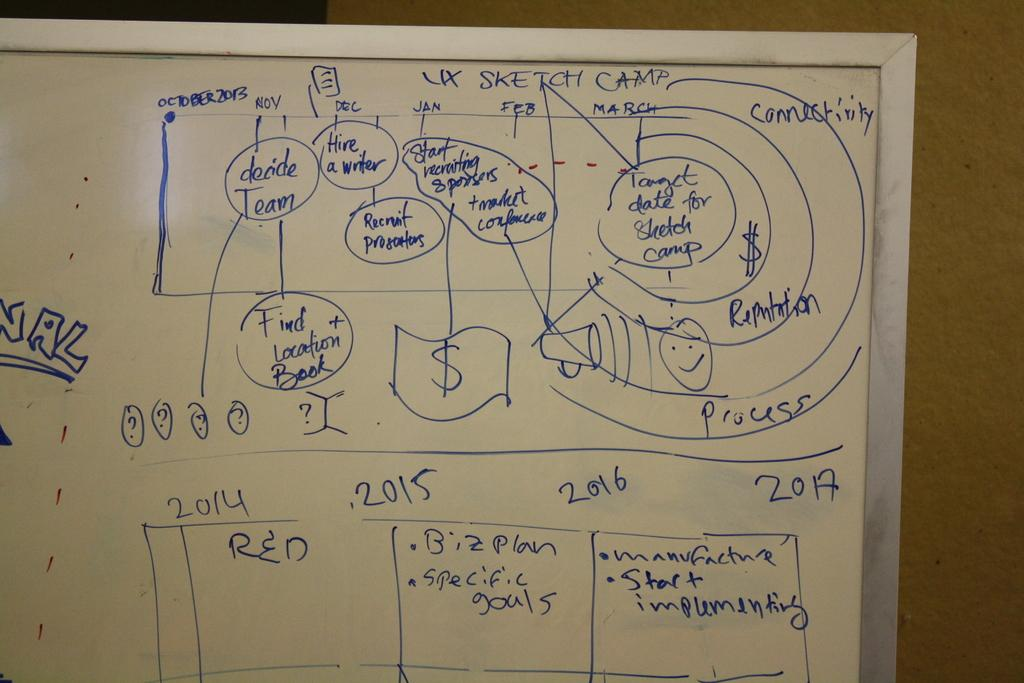<image>
Present a compact description of the photo's key features. A timeline for finishing a project that started in October 2013. 